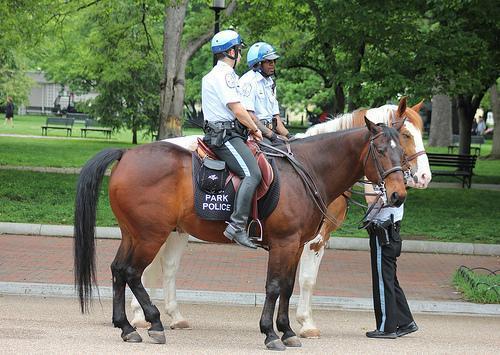How many horses are there?
Give a very brief answer. 2. How many black horses in the image?
Give a very brief answer. 0. 